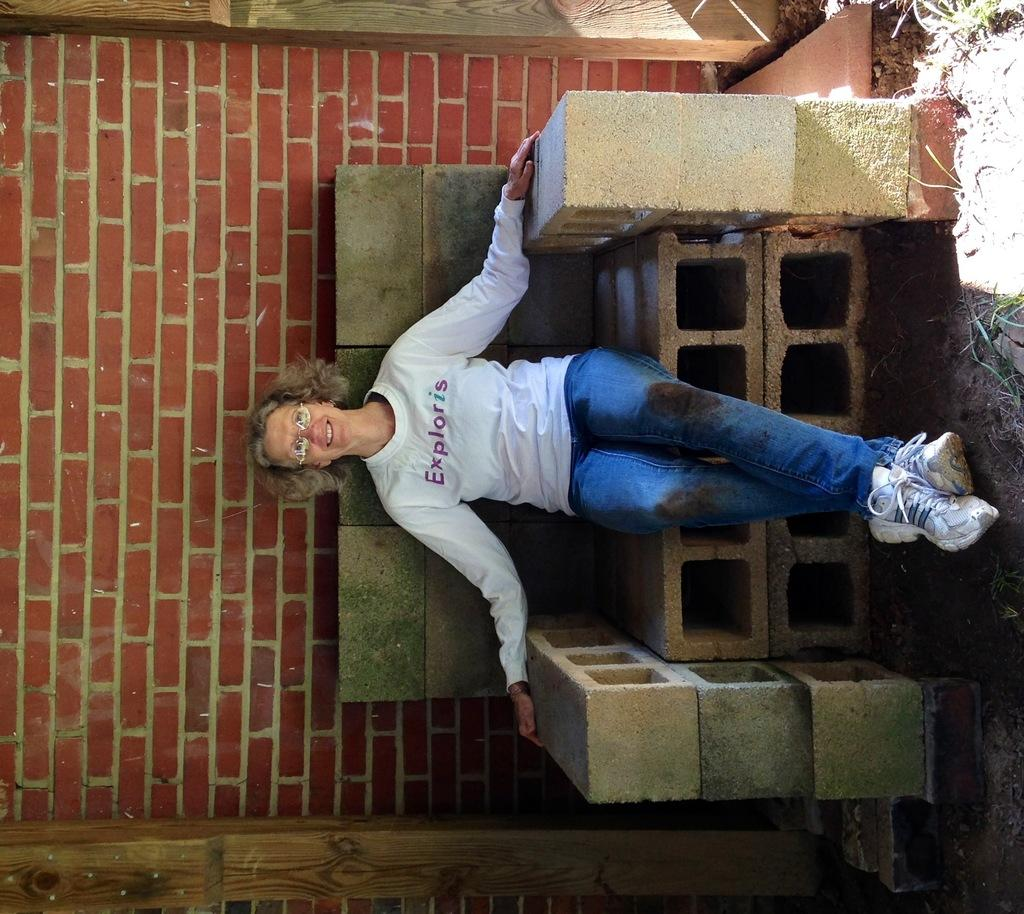What is the person in the image doing? There is a person sitting on a bench in the image. What can be seen in the background of the image? There is a wall in the background of the image. What letters are the person paying attention to in the image? There are no letters visible in the image, and the person's attention is not mentioned. What scientific discovery is being made in the image? There is no scientific discovery being made in the image; it simply shows a person sitting on a bench with a wall in the background. 